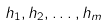<formula> <loc_0><loc_0><loc_500><loc_500>h _ { 1 } , h _ { 2 } , \dots , h _ { m }</formula> 